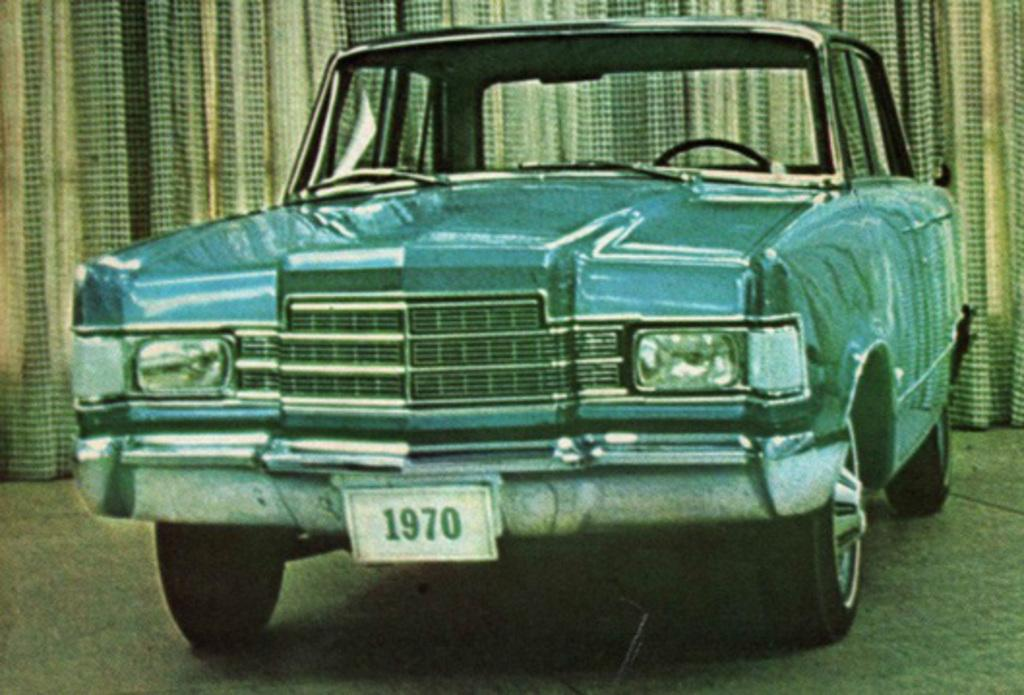What is the main subject of the image? The main subject of the image is a car. Can you describe the car's position in the image? The car is on a surface in the image. What else can be seen in the background of the image? There is a curtain visible in the background of the image. How many light cords are connected to the car in the image? There are no light cords connected to the car in the image. What type of cars can be seen driving in the background of the image? There are no other cars visible in the image; only one car is present. 